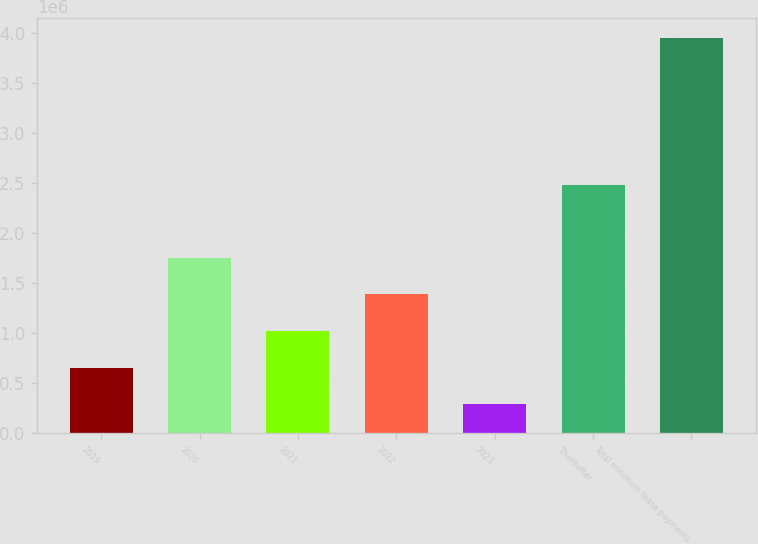<chart> <loc_0><loc_0><loc_500><loc_500><bar_chart><fcel>2019<fcel>2020<fcel>2021<fcel>2022<fcel>2023<fcel>Thereafter<fcel>Total minimum lease payments<nl><fcel>656920<fcel>1.75474e+06<fcel>1.02286e+06<fcel>1.3888e+06<fcel>290980<fcel>2.4784e+06<fcel>3.95038e+06<nl></chart> 